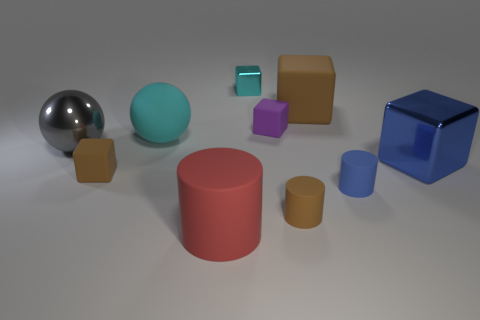How does the lighting in this scene affect the appearance of the objects? The lighting in the scene creates soft shadows and highlights on the objects, enhancing their three-dimensionality. The reflective surfaces, such as the shiny metal and blue cube, have pronounced highlights which show the light source's impact more dramatically compared to the matte textured objects. 